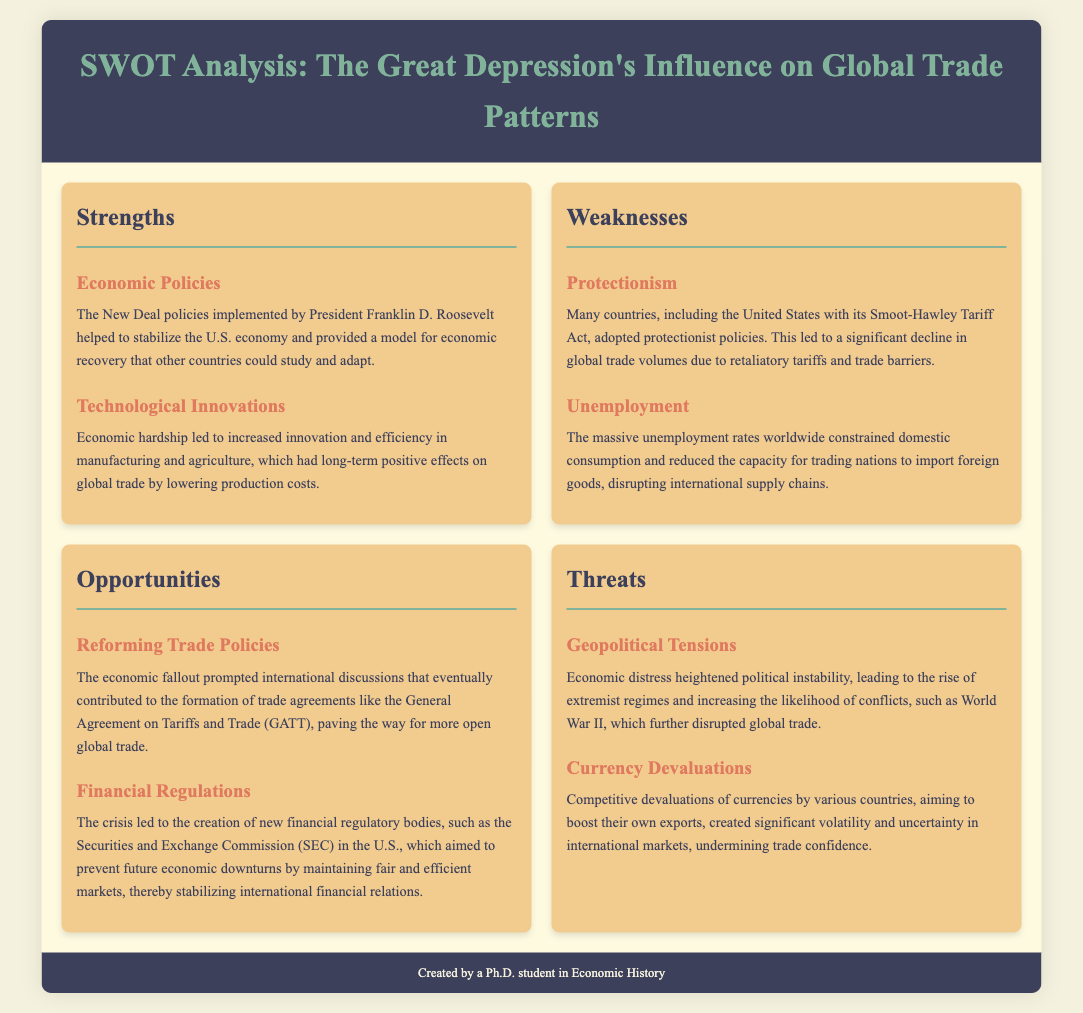What economic policies helped stabilize the U.S. economy during the Great Depression? The document mentions the New Deal policies implemented by President Franklin D. Roosevelt as helping to stabilize the U.S. economy.
Answer: New Deal policies What protectionist policy did the United States adopt during the Great Depression? The document states that the Smoot-Hawley Tariff Act was a protectionist policy adopted by the United States.
Answer: Smoot-Hawley Tariff Act What long-term impact did technological innovations have on global trade? The document indicates that increased innovation and efficiency in manufacturing and agriculture led to long-term positive effects on global trade by lowering production costs.
Answer: Lowering production costs Which international agreement was influenced by the economic fallout of the Great Depression? The document mentions the General Agreement on Tariffs and Trade (GATT) as being influenced by the economic fallout.
Answer: General Agreement on Tariffs and Trade What threat did competitive currency devaluations pose to international markets? According to the document, competitive devaluations of currencies created significant volatility and uncertainty in international markets.
Answer: Volatility and uncertainty How did massive unemployment affect global trade? The document states that massive unemployment constrained domestic consumption and reduced the capacity for trading nations to import foreign goods.
Answer: Reduced capacity for importing goods What type of market did the creation of new financial regulatory bodies aim to maintain? The document specifies that the regulatory bodies aimed to maintain fair and efficient markets.
Answer: Fair and efficient markets What geopolitical impact did economic distress have during the Great Depression? The document explains that economic distress heightened political instability, leading to the rise of extremist regimes.
Answer: Rise of extremist regimes 